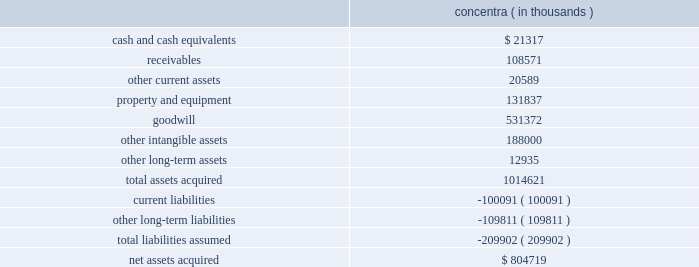Humana inc .
Notes to consolidated financial statements 2014 ( continued ) 3 .
Acquisitions on december 21 , 2010 , we acquired concentra inc. , or concentra , a health care company based in addison , texas , for cash consideration of $ 804.7 million .
Through its affiliated clinicians , concentra delivers occupational medicine , urgent care , physical therapy , and wellness services to workers and the general public through its operation of medical centers and worksite medical facilities .
The concentra acquisition provides entry into the primary care space on a national scale , offering additional means for achieving health and wellness solutions and providing an expandable platform for growth with a management team experienced in physician asset management and alternate site care .
The preliminary fair values of concentra 2019s assets acquired and liabilities assumed at the date of the acquisition are summarized as follows : concentra ( in thousands ) .
The other intangible assets , which primarily consist of customer relationships and trade name , have a weighted average useful life of 13.7 years .
Approximately $ 57.9 million of the acquired goodwill is deductible for tax purposes .
The purchase price allocation is preliminary , subject to completion of valuation analyses , including , for example , refining assumptions used to calculate the fair value of other intangible assets .
The purchase agreement contains provisions under which there may be future consideration paid or received related to the subsequent determination of working capital that existed at the acquisition date .
Any payments or receipts for provisional amounts for working capital will be recorded as an adjustment to goodwill when paid or received .
The results of operations and financial condition of concentra have been included in our consolidated statements of income and consolidated balance sheets from the acquisition date .
In connection with the acquisition , we recognized approximately $ 14.9 million of acquisition-related costs , primarily banker and other professional fees , in selling , general and administrative expense .
The proforma financial information assuming the acquisition had occurred as of january 1 , 2009 was not material to our results of operations .
On october 31 , 2008 , we acquired php companies , inc .
( d/b/a cariten healthcare ) , or cariten , for cash consideration of approximately $ 291.0 million , including the payment of $ 34.9 million during 2010 to settle a purchase price contingency .
The cariten acquisition increased our commercial fully-insured and aso presence as well as our medicare hmo presence in eastern tennessee .
During 2009 , we continued our review of the fair value estimate of certain other intangible and net tangible assets acquired .
This review resulted in a decrease of $ 27.1 million in the fair value of other intangible assets , primarily related to the fair value assigned to the customer contracts acquired .
There was a corresponding adjustment to goodwill and deferred income taxes .
The .
What is the ratio of total assets acquired to total liabilities assumed? 
Computations: (1014621 / 209902)
Answer: 4.83378. 